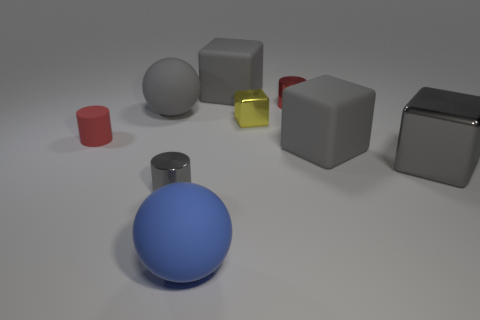There is a cylinder left of the small gray cylinder; is it the same size as the ball that is behind the big gray metal thing?
Keep it short and to the point. No. There is a gray metal thing that is in front of the metal block in front of the yellow metallic block; what is its shape?
Provide a succinct answer. Cylinder. Is the number of big spheres behind the yellow shiny cube the same as the number of large gray rubber objects?
Your response must be concise. No. There is a small cylinder right of the big thing behind the red cylinder right of the small red matte thing; what is it made of?
Your answer should be very brief. Metal. Are there any rubber spheres that have the same size as the red metal cylinder?
Offer a very short reply. No. What is the shape of the tiny yellow metallic object?
Your answer should be compact. Cube. What number of blocks are either large blue matte objects or small objects?
Ensure brevity in your answer.  1. Are there an equal number of tiny yellow blocks that are behind the tiny red metallic object and gray shiny things that are right of the gray shiny cylinder?
Provide a short and direct response. No. How many cubes are on the left side of the matte block to the left of the gray matte thing in front of the gray rubber sphere?
Make the answer very short. 0. What is the shape of the tiny metallic thing that is the same color as the big shiny object?
Give a very brief answer. Cylinder. 